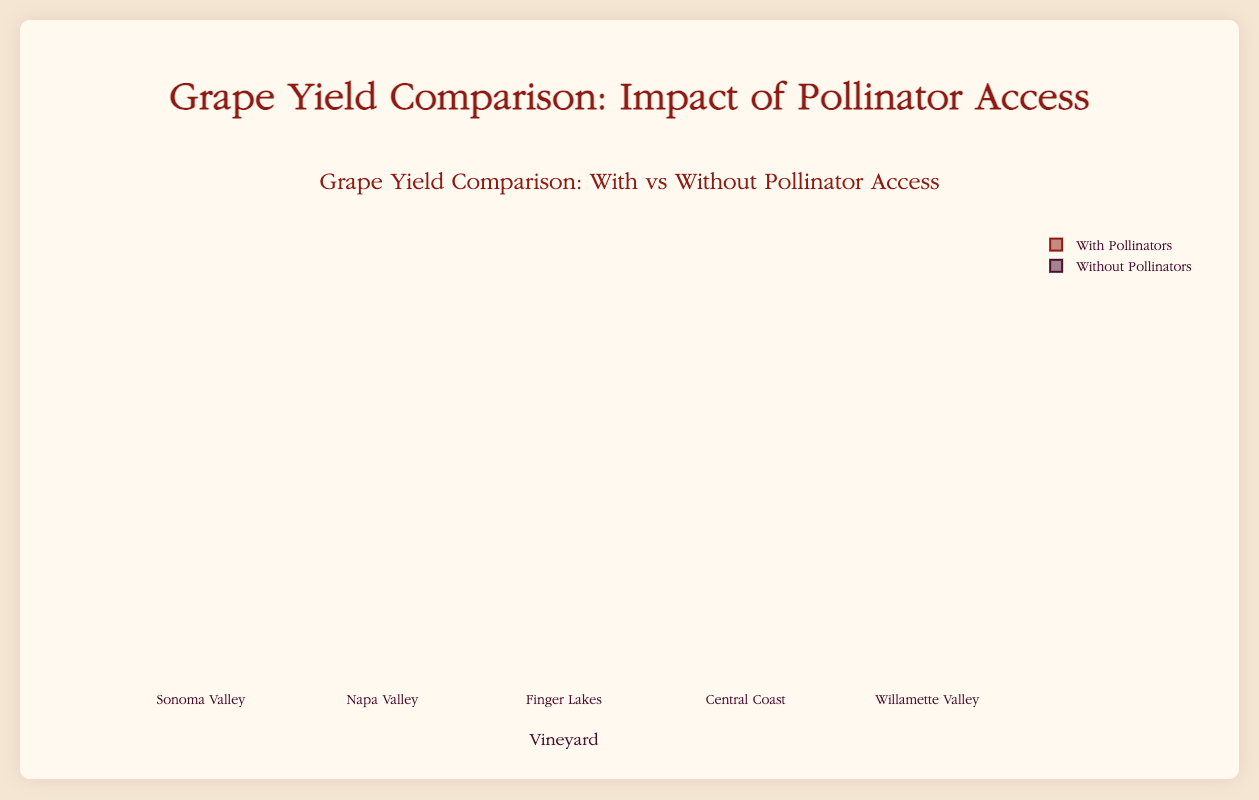How many vineyards are represented in the box plot? The box plot shows data for six vineyards, which can be identified by observing the x-axis labels.
Answer: Six Which vineyard has the highest median yield with pollinators? The Willamette Valley has the highest median yield with pollinators, as its box plot is positioned highest on the y-axis among all vineyards in the "With Pollinators" category.
Answer: Willamette Valley What is the approximate range of grape yield for Napa Valley without pollinators? The range is determined by the spread of the box plot from minimum to maximum values. For Napa Valley without pollinators, the yield ranges from about 810 to 835 kg per hectare.
Answer: 810-835 kg/ha Compare the median grape yield with and without pollinators for Texas Hill Country. The median yield with pollinators is higher than without pollinators. This can be seen by comparing the middle line in each box plot for Texas Hill Country: with pollinators, the median is around 860 kg per hectare, while without pollinators, it is around 770 kg per hectare.
Answer: With: 860, Without: 770 Which vineyard shows the smallest impact of pollinators on yield? The Central Coast shows the smallest impact, as the difference between the medians for with and without pollinators is the smallest among all vineyards.
Answer: Central Coast What is the approximate interquartile range (IQR) of the grape yield for Willamette Valley with pollinators? The IQR is the difference between the third quartile (Q3) and the first quartile (Q1). For Willamette Valley with pollinators, Q1 is around 945 kg/ha and Q3 is around 955 kg/ha, giving an IQR of 10 kg/ha.
Answer: 10 kg/ha For which vineyards does the grape yield increase by more than 100 kg/ha with the presence of pollinators? Compare the median values for each vineyard with and without pollinators. Napa Valley, Finger Lakes, and Texas Hill Country show an increase of more than 100 kg/ha.
Answer: Napa Valley, Finger Lakes, Texas Hill Country What is the maximum grape yield observed with pollinators among all vineyards? Look for the highest value on the y-axis in the "With Pollinators" category. The maximum yield observed is around 960 kg/ha in Willamette Valley.
Answer: 960 kg/ha 